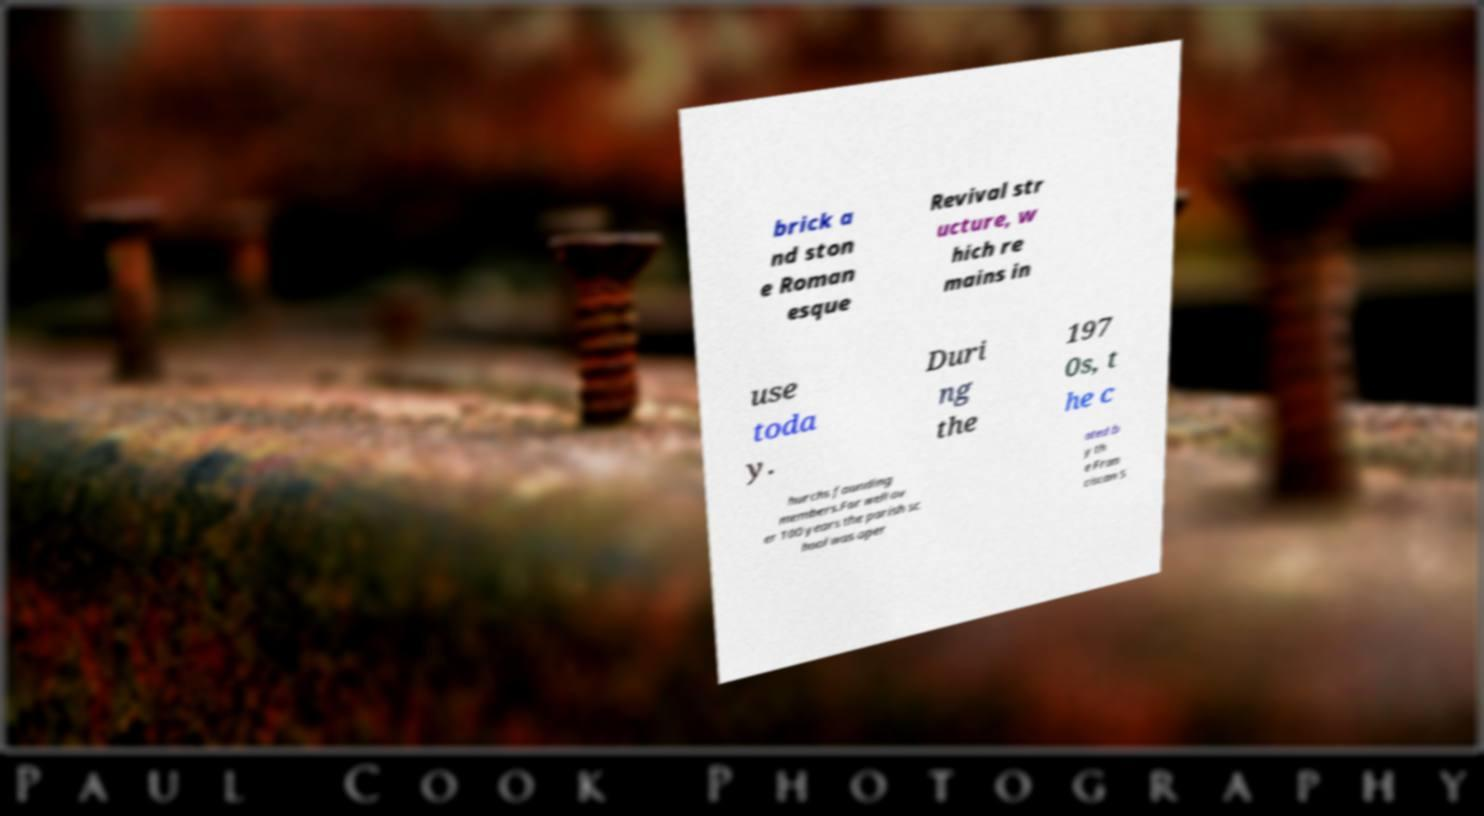Please identify and transcribe the text found in this image. brick a nd ston e Roman esque Revival str ucture, w hich re mains in use toda y. Duri ng the 197 0s, t he c hurchs founding members.For well ov er 100 years the parish sc hool was oper ated b y th e Fran ciscan S 